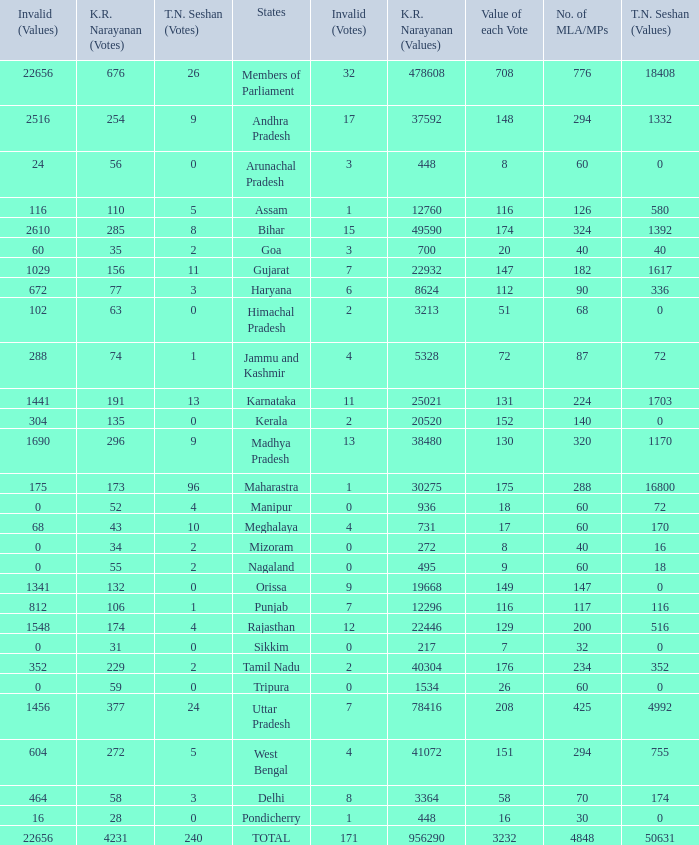Name the kr narayanan votes for values being 936 for kr 52.0. 